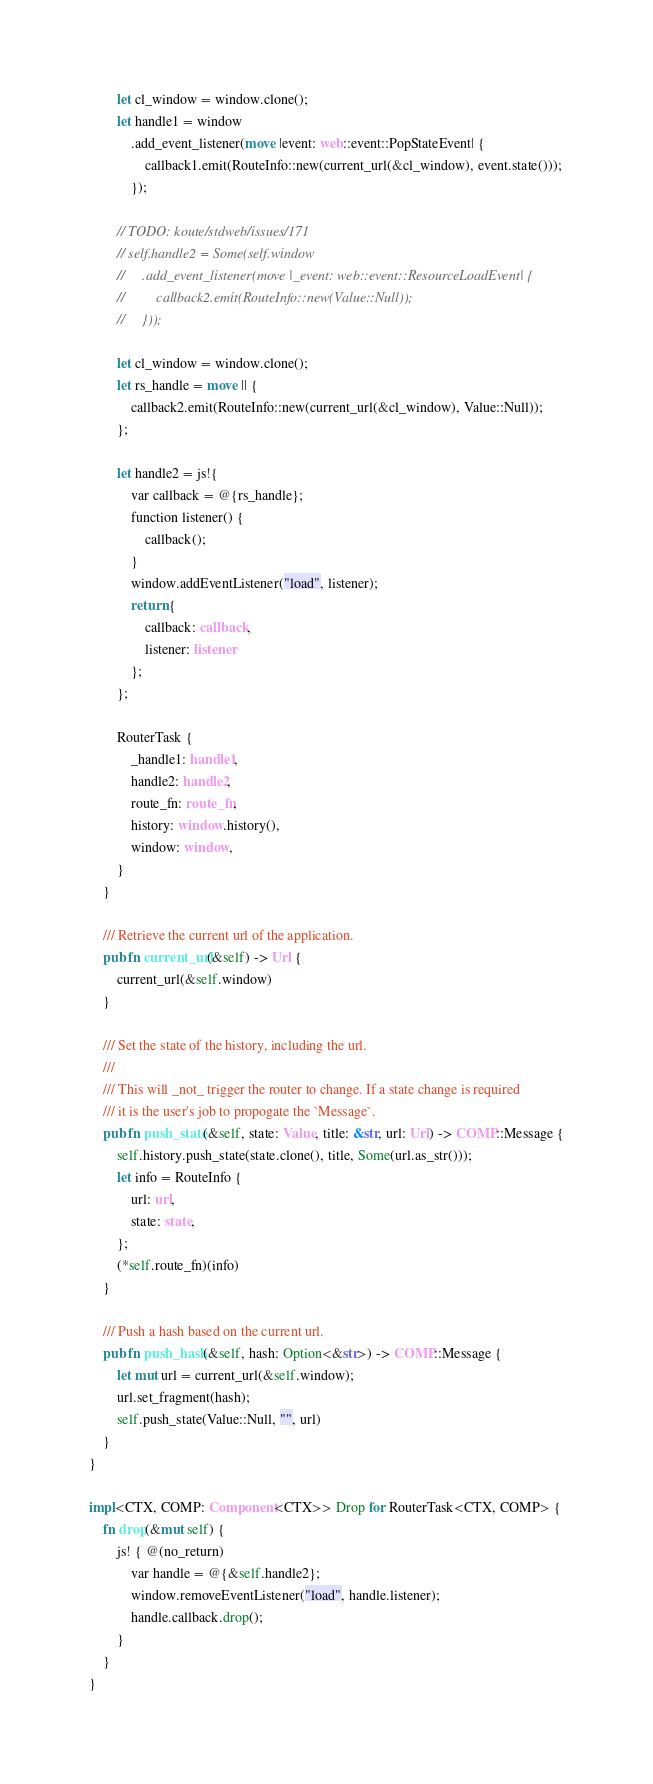<code> <loc_0><loc_0><loc_500><loc_500><_Rust_>        let cl_window = window.clone();
        let handle1 = window
            .add_event_listener(move |event: web::event::PopStateEvent| {
                callback1.emit(RouteInfo::new(current_url(&cl_window), event.state()));
            });

        // TODO: koute/stdweb/issues/171
        // self.handle2 = Some(self.window
        //     .add_event_listener(move |_event: web::event::ResourceLoadEvent| {
        //         callback2.emit(RouteInfo::new(Value::Null));
        //     }));

        let cl_window = window.clone();
        let rs_handle = move || {
            callback2.emit(RouteInfo::new(current_url(&cl_window), Value::Null));
        };

        let handle2 = js!{
            var callback = @{rs_handle};
            function listener() {
                callback();
            }
            window.addEventListener("load", listener);
            return {
                callback: callback,
                listener: listener
            };
        };

        RouterTask {
            _handle1: handle1,
            handle2: handle2,
            route_fn: route_fn,
            history: window.history(),
            window: window,
        }
    }

    /// Retrieve the current url of the application.
    pub fn current_url(&self) -> Url {
        current_url(&self.window)
    }

    /// Set the state of the history, including the url.
    ///
    /// This will _not_ trigger the router to change. If a state change is required
    /// it is the user's job to propogate the `Message`.
    pub fn push_state(&self, state: Value, title: &str, url: Url) -> COMP::Message {
        self.history.push_state(state.clone(), title, Some(url.as_str()));
        let info = RouteInfo {
            url: url,
            state: state,
        };
        (*self.route_fn)(info)
    }

    /// Push a hash based on the current url.
    pub fn push_hash(&self, hash: Option<&str>) -> COMP::Message {
        let mut url = current_url(&self.window);
        url.set_fragment(hash);
        self.push_state(Value::Null, "", url)
    }
}

impl<CTX, COMP: Component<CTX>> Drop for RouterTask<CTX, COMP> {
    fn drop(&mut self) {
        js! { @(no_return)
            var handle = @{&self.handle2};
            window.removeEventListener("load", handle.listener);
            handle.callback.drop();
        }
    }
}

</code> 